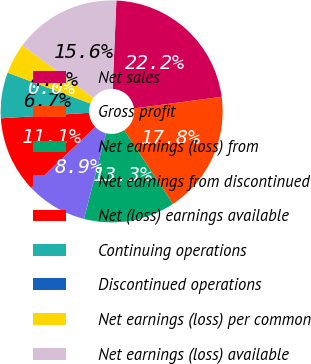Convert chart to OTSL. <chart><loc_0><loc_0><loc_500><loc_500><pie_chart><fcel>Net sales<fcel>Gross profit<fcel>Net earnings (loss) from<fcel>Net earnings from discontinued<fcel>Net (loss) earnings available<fcel>Continuing operations<fcel>Discontinued operations<fcel>Net earnings (loss) per common<fcel>Net earnings (loss) available<nl><fcel>22.22%<fcel>17.78%<fcel>13.33%<fcel>8.89%<fcel>11.11%<fcel>6.67%<fcel>0.0%<fcel>4.44%<fcel>15.56%<nl></chart> 